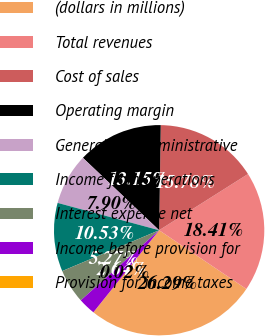Convert chart. <chart><loc_0><loc_0><loc_500><loc_500><pie_chart><fcel>(dollars in millions)<fcel>Total revenues<fcel>Cost of sales<fcel>Operating margin<fcel>General and administrative<fcel>Income from operations<fcel>Interest expense net<fcel>Income before provision for<fcel>Provision for income taxes<nl><fcel>26.29%<fcel>18.41%<fcel>15.78%<fcel>13.15%<fcel>7.9%<fcel>10.53%<fcel>5.27%<fcel>2.64%<fcel>0.02%<nl></chart> 